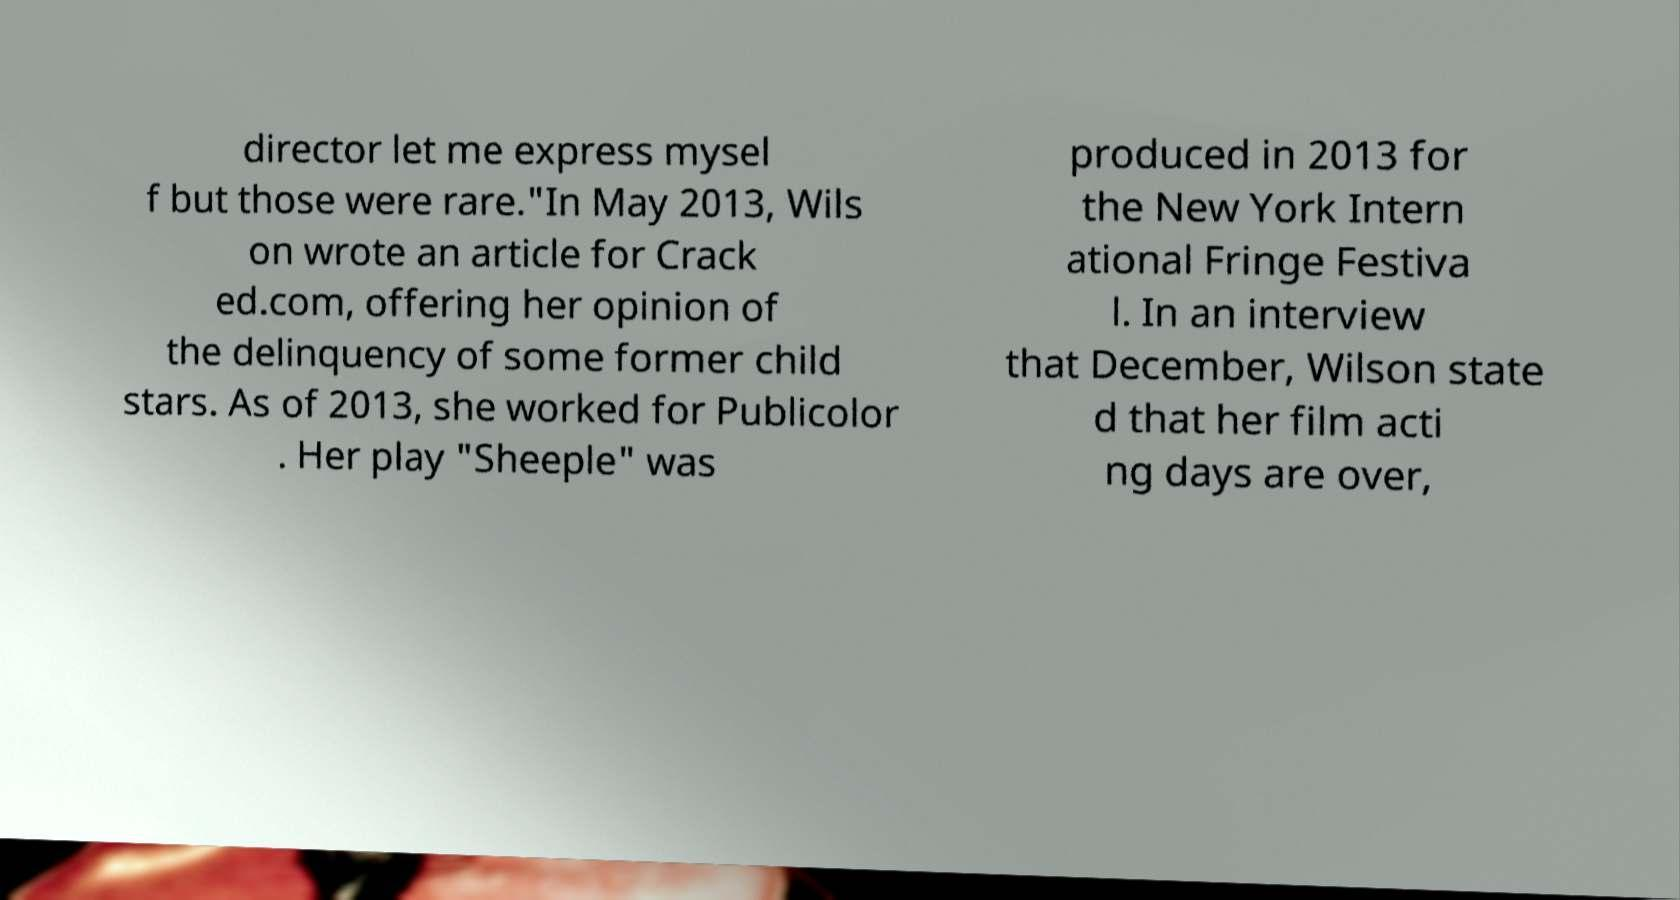For documentation purposes, I need the text within this image transcribed. Could you provide that? director let me express mysel f but those were rare."In May 2013, Wils on wrote an article for Crack ed.com, offering her opinion of the delinquency of some former child stars. As of 2013, she worked for Publicolor . Her play "Sheeple" was produced in 2013 for the New York Intern ational Fringe Festiva l. In an interview that December, Wilson state d that her film acti ng days are over, 